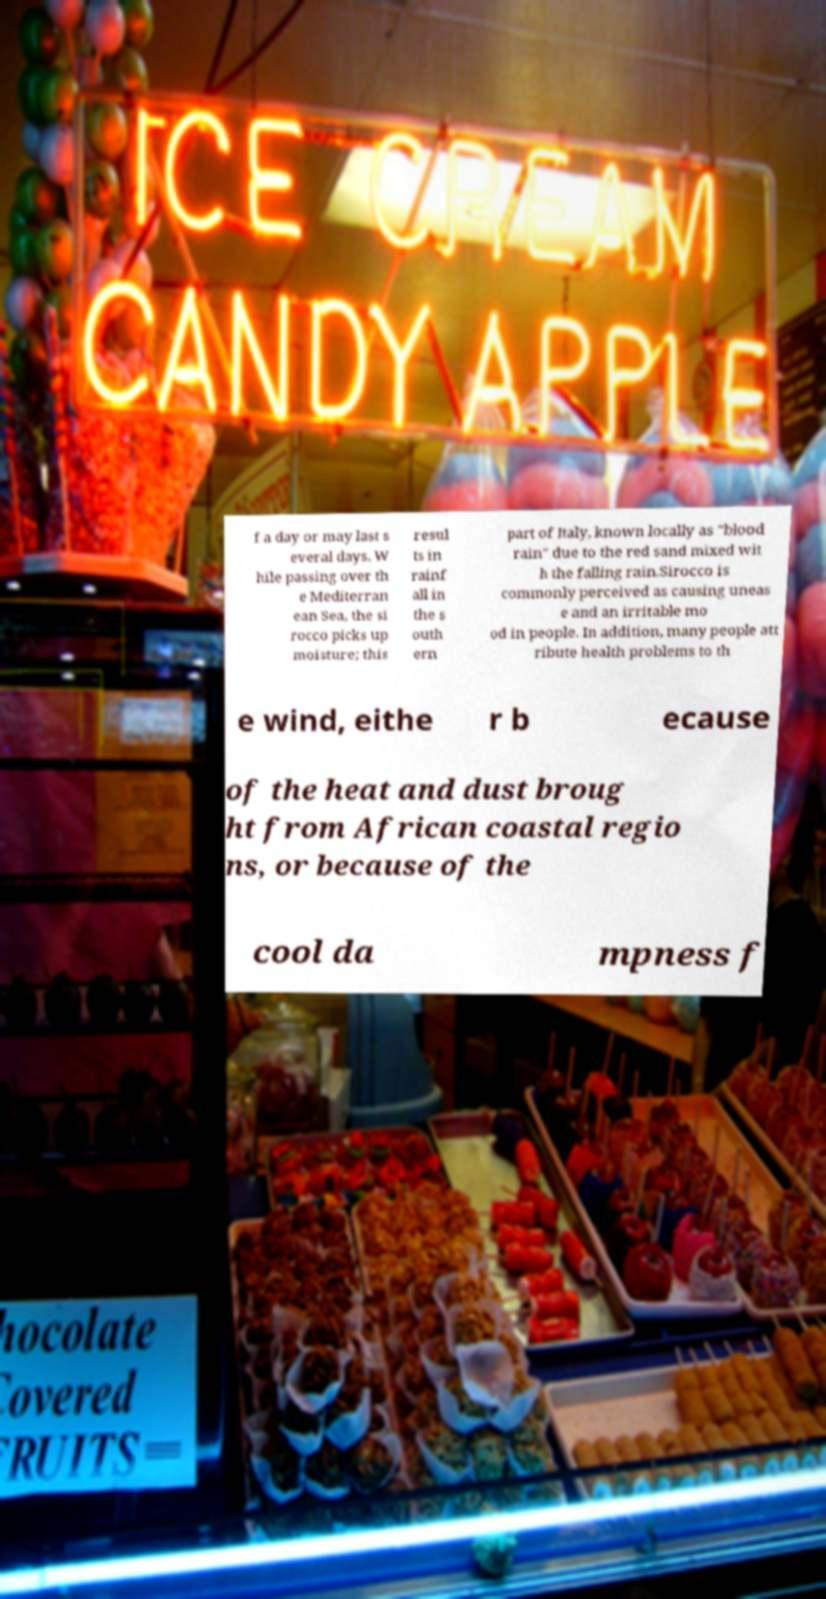What messages or text are displayed in this image? I need them in a readable, typed format. f a day or may last s everal days. W hile passing over th e Mediterran ean Sea, the si rocco picks up moisture; this resul ts in rainf all in the s outh ern part of Italy, known locally as "blood rain" due to the red sand mixed wit h the falling rain.Sirocco is commonly perceived as causing uneas e and an irritable mo od in people. In addition, many people att ribute health problems to th e wind, eithe r b ecause of the heat and dust broug ht from African coastal regio ns, or because of the cool da mpness f 